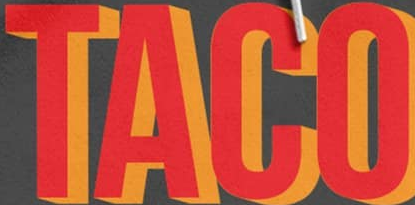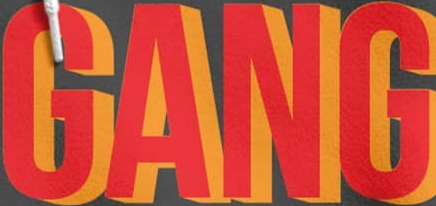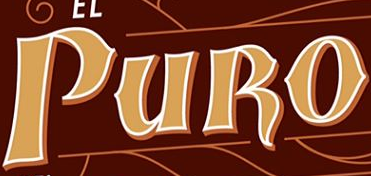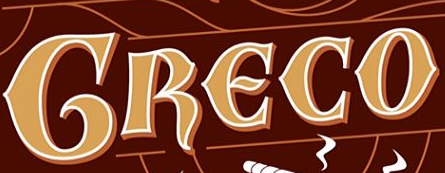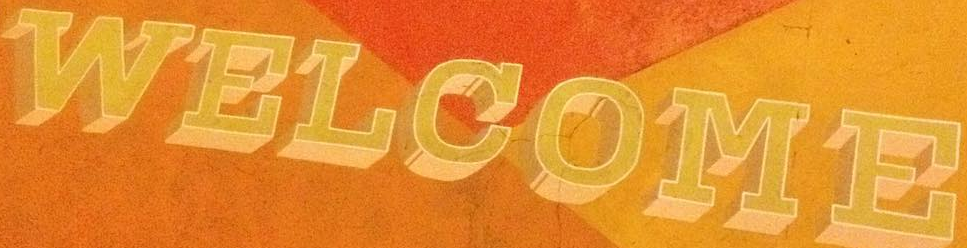Transcribe the words shown in these images in order, separated by a semicolon. TACO; GANG; PURO; GRECO; WELCOME 